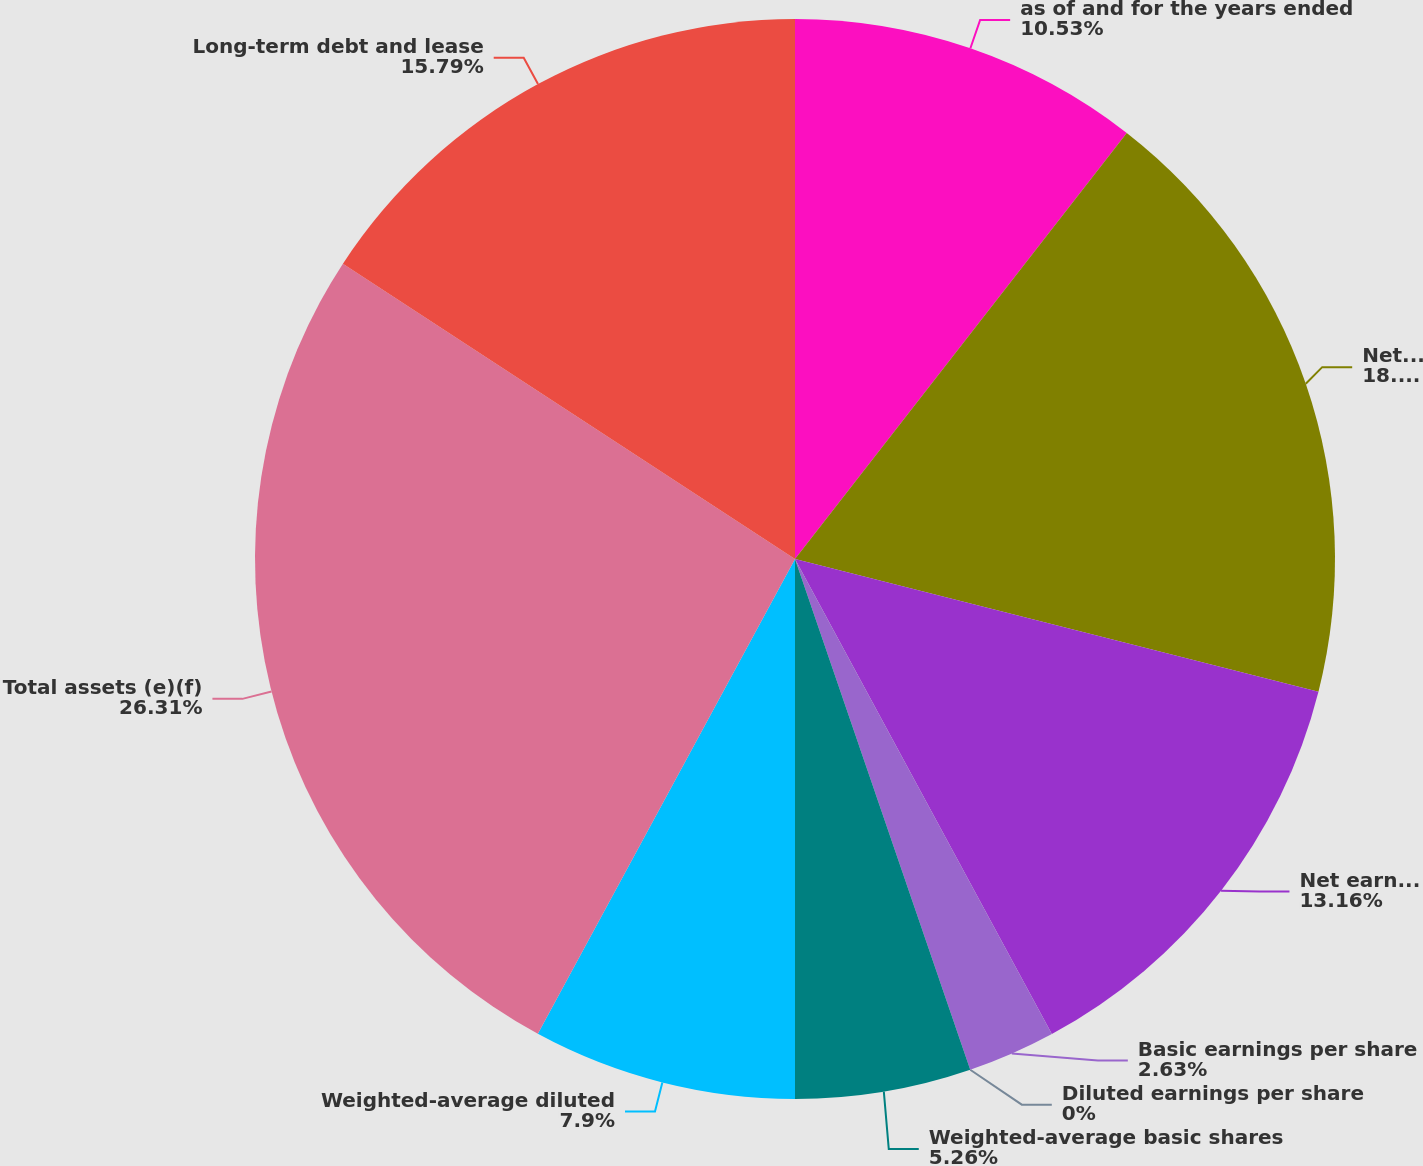Convert chart to OTSL. <chart><loc_0><loc_0><loc_500><loc_500><pie_chart><fcel>as of and for the years ended<fcel>Net revenues<fcel>Net earnings (a)(b)<fcel>Basic earnings per share<fcel>Diluted earnings per share<fcel>Weighted-average basic shares<fcel>Weighted-average diluted<fcel>Total assets (e)(f)<fcel>Long-term debt and lease<nl><fcel>10.53%<fcel>18.42%<fcel>13.16%<fcel>2.63%<fcel>0.0%<fcel>5.26%<fcel>7.9%<fcel>26.31%<fcel>15.79%<nl></chart> 